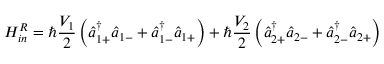<formula> <loc_0><loc_0><loc_500><loc_500>H _ { i n } ^ { R } = \hbar { } V _ { 1 } } { 2 } \left ( \hat { a } _ { 1 + } ^ { \dagger } \hat { a } _ { 1 - } + \hat { a } _ { 1 - } ^ { \dagger } \hat { a } _ { 1 + } \right ) + \hbar { } V _ { 2 } } { 2 } \left ( \hat { a } _ { 2 + } ^ { \dagger } \hat { a } _ { 2 - } + \hat { a } _ { 2 - } ^ { \dagger } \hat { a } _ { 2 + } \right )</formula> 